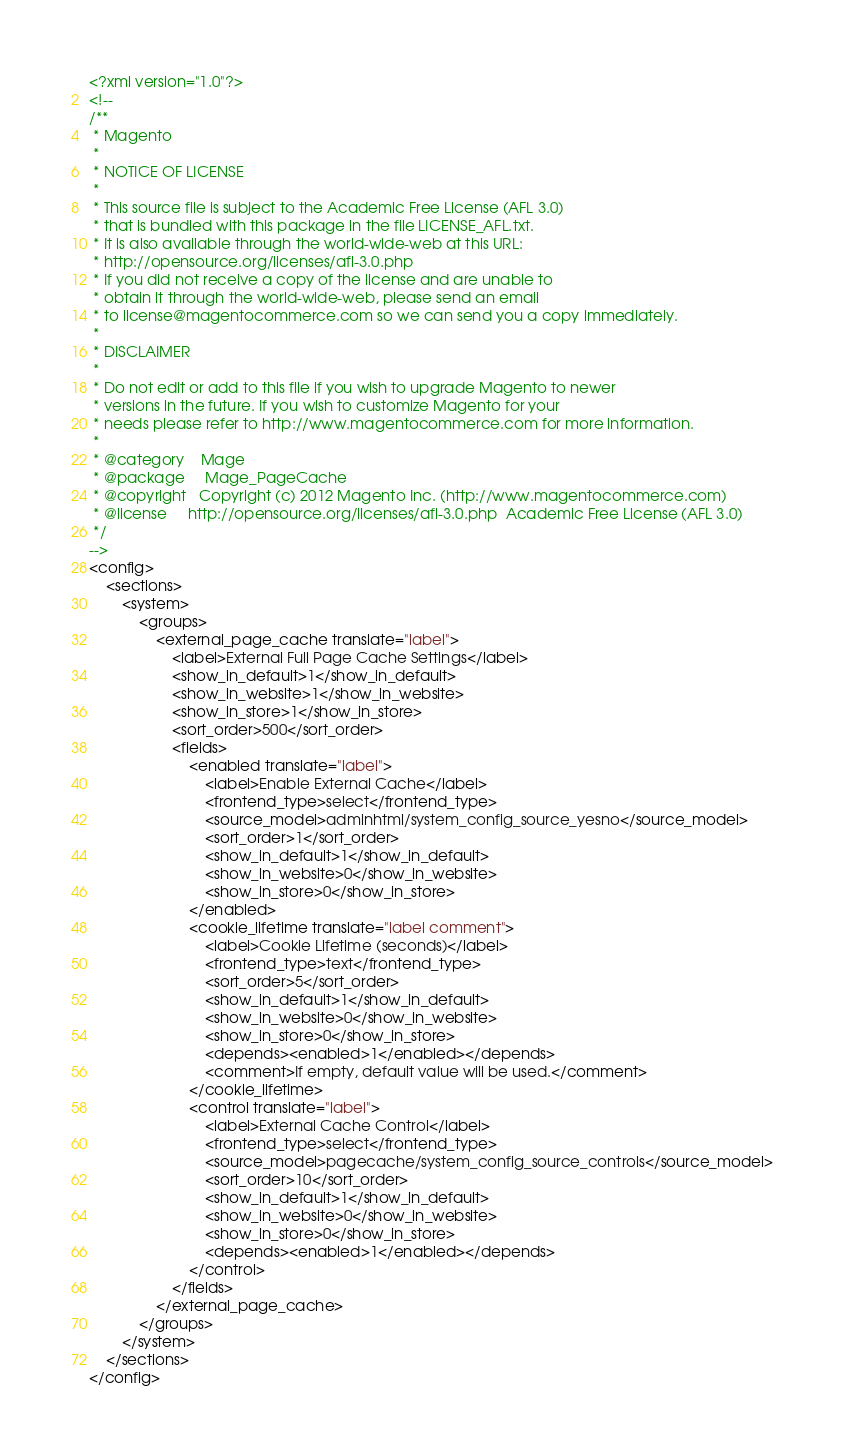<code> <loc_0><loc_0><loc_500><loc_500><_XML_><?xml version="1.0"?>
<!--
/**
 * Magento
 *
 * NOTICE OF LICENSE
 *
 * This source file is subject to the Academic Free License (AFL 3.0)
 * that is bundled with this package in the file LICENSE_AFL.txt.
 * It is also available through the world-wide-web at this URL:
 * http://opensource.org/licenses/afl-3.0.php
 * If you did not receive a copy of the license and are unable to
 * obtain it through the world-wide-web, please send an email
 * to license@magentocommerce.com so we can send you a copy immediately.
 *
 * DISCLAIMER
 *
 * Do not edit or add to this file if you wish to upgrade Magento to newer
 * versions in the future. If you wish to customize Magento for your
 * needs please refer to http://www.magentocommerce.com for more information.
 *
 * @category    Mage
 * @package     Mage_PageCache
 * @copyright   Copyright (c) 2012 Magento Inc. (http://www.magentocommerce.com)
 * @license     http://opensource.org/licenses/afl-3.0.php  Academic Free License (AFL 3.0)
 */
-->
<config>
    <sections>
        <system>
            <groups>
                <external_page_cache translate="label">
                    <label>External Full Page Cache Settings</label>
                    <show_in_default>1</show_in_default>
                    <show_in_website>1</show_in_website>
                    <show_in_store>1</show_in_store>
                    <sort_order>500</sort_order>
                    <fields>
                        <enabled translate="label">
                            <label>Enable External Cache</label>
                            <frontend_type>select</frontend_type>
                            <source_model>adminhtml/system_config_source_yesno</source_model>
                            <sort_order>1</sort_order>
                            <show_in_default>1</show_in_default>
                            <show_in_website>0</show_in_website>
                            <show_in_store>0</show_in_store>
                        </enabled>
                        <cookie_lifetime translate="label comment">
                            <label>Cookie Lifetime (seconds)</label>
                            <frontend_type>text</frontend_type>
                            <sort_order>5</sort_order>
                            <show_in_default>1</show_in_default>
                            <show_in_website>0</show_in_website>
                            <show_in_store>0</show_in_store>
                            <depends><enabled>1</enabled></depends>
                            <comment>If empty, default value will be used.</comment>
                        </cookie_lifetime>
                        <control translate="label">
                            <label>External Cache Control</label>
                            <frontend_type>select</frontend_type>
                            <source_model>pagecache/system_config_source_controls</source_model>
                            <sort_order>10</sort_order>
                            <show_in_default>1</show_in_default>
                            <show_in_website>0</show_in_website>
                            <show_in_store>0</show_in_store>
                            <depends><enabled>1</enabled></depends>
                        </control>
                    </fields>
                </external_page_cache>
            </groups>
        </system>
    </sections>
</config>
</code> 